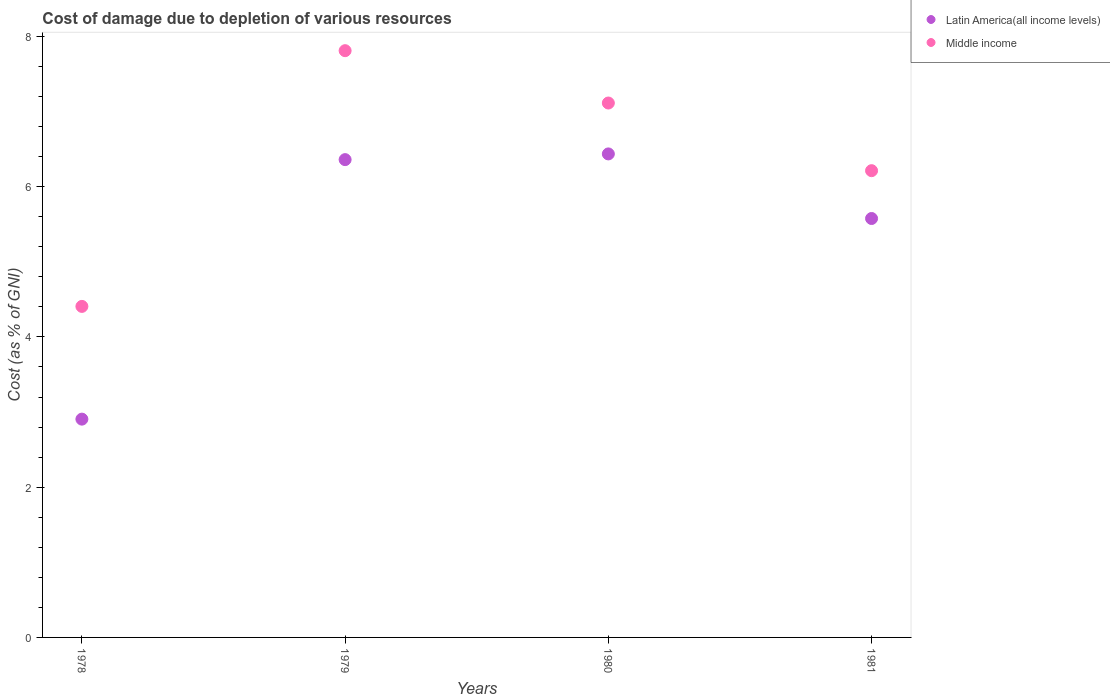How many different coloured dotlines are there?
Give a very brief answer. 2. Is the number of dotlines equal to the number of legend labels?
Your answer should be very brief. Yes. What is the cost of damage caused due to the depletion of various resources in Latin America(all income levels) in 1981?
Offer a very short reply. 5.58. Across all years, what is the maximum cost of damage caused due to the depletion of various resources in Latin America(all income levels)?
Your response must be concise. 6.44. Across all years, what is the minimum cost of damage caused due to the depletion of various resources in Latin America(all income levels)?
Provide a short and direct response. 2.91. In which year was the cost of damage caused due to the depletion of various resources in Middle income maximum?
Offer a terse response. 1979. In which year was the cost of damage caused due to the depletion of various resources in Middle income minimum?
Provide a short and direct response. 1978. What is the total cost of damage caused due to the depletion of various resources in Latin America(all income levels) in the graph?
Provide a succinct answer. 21.28. What is the difference between the cost of damage caused due to the depletion of various resources in Latin America(all income levels) in 1980 and that in 1981?
Offer a terse response. 0.86. What is the difference between the cost of damage caused due to the depletion of various resources in Latin America(all income levels) in 1981 and the cost of damage caused due to the depletion of various resources in Middle income in 1980?
Ensure brevity in your answer.  -1.54. What is the average cost of damage caused due to the depletion of various resources in Middle income per year?
Your answer should be very brief. 6.39. In the year 1978, what is the difference between the cost of damage caused due to the depletion of various resources in Middle income and cost of damage caused due to the depletion of various resources in Latin America(all income levels)?
Offer a very short reply. 1.5. What is the ratio of the cost of damage caused due to the depletion of various resources in Middle income in 1980 to that in 1981?
Your response must be concise. 1.14. Is the difference between the cost of damage caused due to the depletion of various resources in Middle income in 1978 and 1979 greater than the difference between the cost of damage caused due to the depletion of various resources in Latin America(all income levels) in 1978 and 1979?
Make the answer very short. Yes. What is the difference between the highest and the second highest cost of damage caused due to the depletion of various resources in Latin America(all income levels)?
Your answer should be compact. 0.08. What is the difference between the highest and the lowest cost of damage caused due to the depletion of various resources in Middle income?
Keep it short and to the point. 3.4. In how many years, is the cost of damage caused due to the depletion of various resources in Latin America(all income levels) greater than the average cost of damage caused due to the depletion of various resources in Latin America(all income levels) taken over all years?
Offer a very short reply. 3. Is the cost of damage caused due to the depletion of various resources in Middle income strictly greater than the cost of damage caused due to the depletion of various resources in Latin America(all income levels) over the years?
Your answer should be very brief. Yes. Is the cost of damage caused due to the depletion of various resources in Latin America(all income levels) strictly less than the cost of damage caused due to the depletion of various resources in Middle income over the years?
Your answer should be very brief. Yes. How many dotlines are there?
Offer a terse response. 2. How many years are there in the graph?
Offer a very short reply. 4. Does the graph contain any zero values?
Keep it short and to the point. No. How many legend labels are there?
Your answer should be very brief. 2. What is the title of the graph?
Offer a terse response. Cost of damage due to depletion of various resources. What is the label or title of the Y-axis?
Your answer should be compact. Cost (as % of GNI). What is the Cost (as % of GNI) of Latin America(all income levels) in 1978?
Provide a short and direct response. 2.91. What is the Cost (as % of GNI) of Middle income in 1978?
Give a very brief answer. 4.41. What is the Cost (as % of GNI) of Latin America(all income levels) in 1979?
Ensure brevity in your answer.  6.36. What is the Cost (as % of GNI) in Middle income in 1979?
Keep it short and to the point. 7.81. What is the Cost (as % of GNI) of Latin America(all income levels) in 1980?
Provide a succinct answer. 6.44. What is the Cost (as % of GNI) in Middle income in 1980?
Ensure brevity in your answer.  7.11. What is the Cost (as % of GNI) of Latin America(all income levels) in 1981?
Offer a terse response. 5.58. What is the Cost (as % of GNI) of Middle income in 1981?
Offer a terse response. 6.21. Across all years, what is the maximum Cost (as % of GNI) of Latin America(all income levels)?
Give a very brief answer. 6.44. Across all years, what is the maximum Cost (as % of GNI) of Middle income?
Keep it short and to the point. 7.81. Across all years, what is the minimum Cost (as % of GNI) of Latin America(all income levels)?
Keep it short and to the point. 2.91. Across all years, what is the minimum Cost (as % of GNI) in Middle income?
Provide a short and direct response. 4.41. What is the total Cost (as % of GNI) of Latin America(all income levels) in the graph?
Give a very brief answer. 21.28. What is the total Cost (as % of GNI) of Middle income in the graph?
Your answer should be compact. 25.54. What is the difference between the Cost (as % of GNI) in Latin America(all income levels) in 1978 and that in 1979?
Give a very brief answer. -3.45. What is the difference between the Cost (as % of GNI) in Middle income in 1978 and that in 1979?
Your answer should be very brief. -3.4. What is the difference between the Cost (as % of GNI) of Latin America(all income levels) in 1978 and that in 1980?
Your answer should be compact. -3.53. What is the difference between the Cost (as % of GNI) of Middle income in 1978 and that in 1980?
Your answer should be compact. -2.71. What is the difference between the Cost (as % of GNI) of Latin America(all income levels) in 1978 and that in 1981?
Your answer should be very brief. -2.67. What is the difference between the Cost (as % of GNI) in Middle income in 1978 and that in 1981?
Provide a short and direct response. -1.81. What is the difference between the Cost (as % of GNI) in Latin America(all income levels) in 1979 and that in 1980?
Offer a very short reply. -0.08. What is the difference between the Cost (as % of GNI) of Middle income in 1979 and that in 1980?
Give a very brief answer. 0.7. What is the difference between the Cost (as % of GNI) of Latin America(all income levels) in 1979 and that in 1981?
Keep it short and to the point. 0.78. What is the difference between the Cost (as % of GNI) in Middle income in 1979 and that in 1981?
Your response must be concise. 1.6. What is the difference between the Cost (as % of GNI) in Latin America(all income levels) in 1980 and that in 1981?
Offer a terse response. 0.86. What is the difference between the Cost (as % of GNI) in Middle income in 1980 and that in 1981?
Provide a succinct answer. 0.9. What is the difference between the Cost (as % of GNI) of Latin America(all income levels) in 1978 and the Cost (as % of GNI) of Middle income in 1979?
Offer a terse response. -4.9. What is the difference between the Cost (as % of GNI) of Latin America(all income levels) in 1978 and the Cost (as % of GNI) of Middle income in 1980?
Offer a very short reply. -4.21. What is the difference between the Cost (as % of GNI) of Latin America(all income levels) in 1978 and the Cost (as % of GNI) of Middle income in 1981?
Give a very brief answer. -3.31. What is the difference between the Cost (as % of GNI) in Latin America(all income levels) in 1979 and the Cost (as % of GNI) in Middle income in 1980?
Provide a succinct answer. -0.75. What is the difference between the Cost (as % of GNI) of Latin America(all income levels) in 1979 and the Cost (as % of GNI) of Middle income in 1981?
Offer a terse response. 0.15. What is the difference between the Cost (as % of GNI) in Latin America(all income levels) in 1980 and the Cost (as % of GNI) in Middle income in 1981?
Provide a short and direct response. 0.22. What is the average Cost (as % of GNI) in Latin America(all income levels) per year?
Give a very brief answer. 5.32. What is the average Cost (as % of GNI) of Middle income per year?
Ensure brevity in your answer.  6.39. In the year 1978, what is the difference between the Cost (as % of GNI) of Latin America(all income levels) and Cost (as % of GNI) of Middle income?
Offer a terse response. -1.5. In the year 1979, what is the difference between the Cost (as % of GNI) of Latin America(all income levels) and Cost (as % of GNI) of Middle income?
Your answer should be compact. -1.45. In the year 1980, what is the difference between the Cost (as % of GNI) of Latin America(all income levels) and Cost (as % of GNI) of Middle income?
Offer a very short reply. -0.68. In the year 1981, what is the difference between the Cost (as % of GNI) of Latin America(all income levels) and Cost (as % of GNI) of Middle income?
Offer a terse response. -0.64. What is the ratio of the Cost (as % of GNI) of Latin America(all income levels) in 1978 to that in 1979?
Make the answer very short. 0.46. What is the ratio of the Cost (as % of GNI) in Middle income in 1978 to that in 1979?
Your answer should be very brief. 0.56. What is the ratio of the Cost (as % of GNI) in Latin America(all income levels) in 1978 to that in 1980?
Your answer should be compact. 0.45. What is the ratio of the Cost (as % of GNI) of Middle income in 1978 to that in 1980?
Your answer should be compact. 0.62. What is the ratio of the Cost (as % of GNI) of Latin America(all income levels) in 1978 to that in 1981?
Offer a very short reply. 0.52. What is the ratio of the Cost (as % of GNI) in Middle income in 1978 to that in 1981?
Give a very brief answer. 0.71. What is the ratio of the Cost (as % of GNI) in Latin America(all income levels) in 1979 to that in 1980?
Provide a succinct answer. 0.99. What is the ratio of the Cost (as % of GNI) in Middle income in 1979 to that in 1980?
Your answer should be compact. 1.1. What is the ratio of the Cost (as % of GNI) in Latin America(all income levels) in 1979 to that in 1981?
Offer a very short reply. 1.14. What is the ratio of the Cost (as % of GNI) in Middle income in 1979 to that in 1981?
Your answer should be compact. 1.26. What is the ratio of the Cost (as % of GNI) of Latin America(all income levels) in 1980 to that in 1981?
Your response must be concise. 1.15. What is the ratio of the Cost (as % of GNI) of Middle income in 1980 to that in 1981?
Offer a very short reply. 1.15. What is the difference between the highest and the second highest Cost (as % of GNI) of Latin America(all income levels)?
Ensure brevity in your answer.  0.08. What is the difference between the highest and the second highest Cost (as % of GNI) of Middle income?
Provide a short and direct response. 0.7. What is the difference between the highest and the lowest Cost (as % of GNI) of Latin America(all income levels)?
Ensure brevity in your answer.  3.53. What is the difference between the highest and the lowest Cost (as % of GNI) in Middle income?
Your answer should be compact. 3.4. 